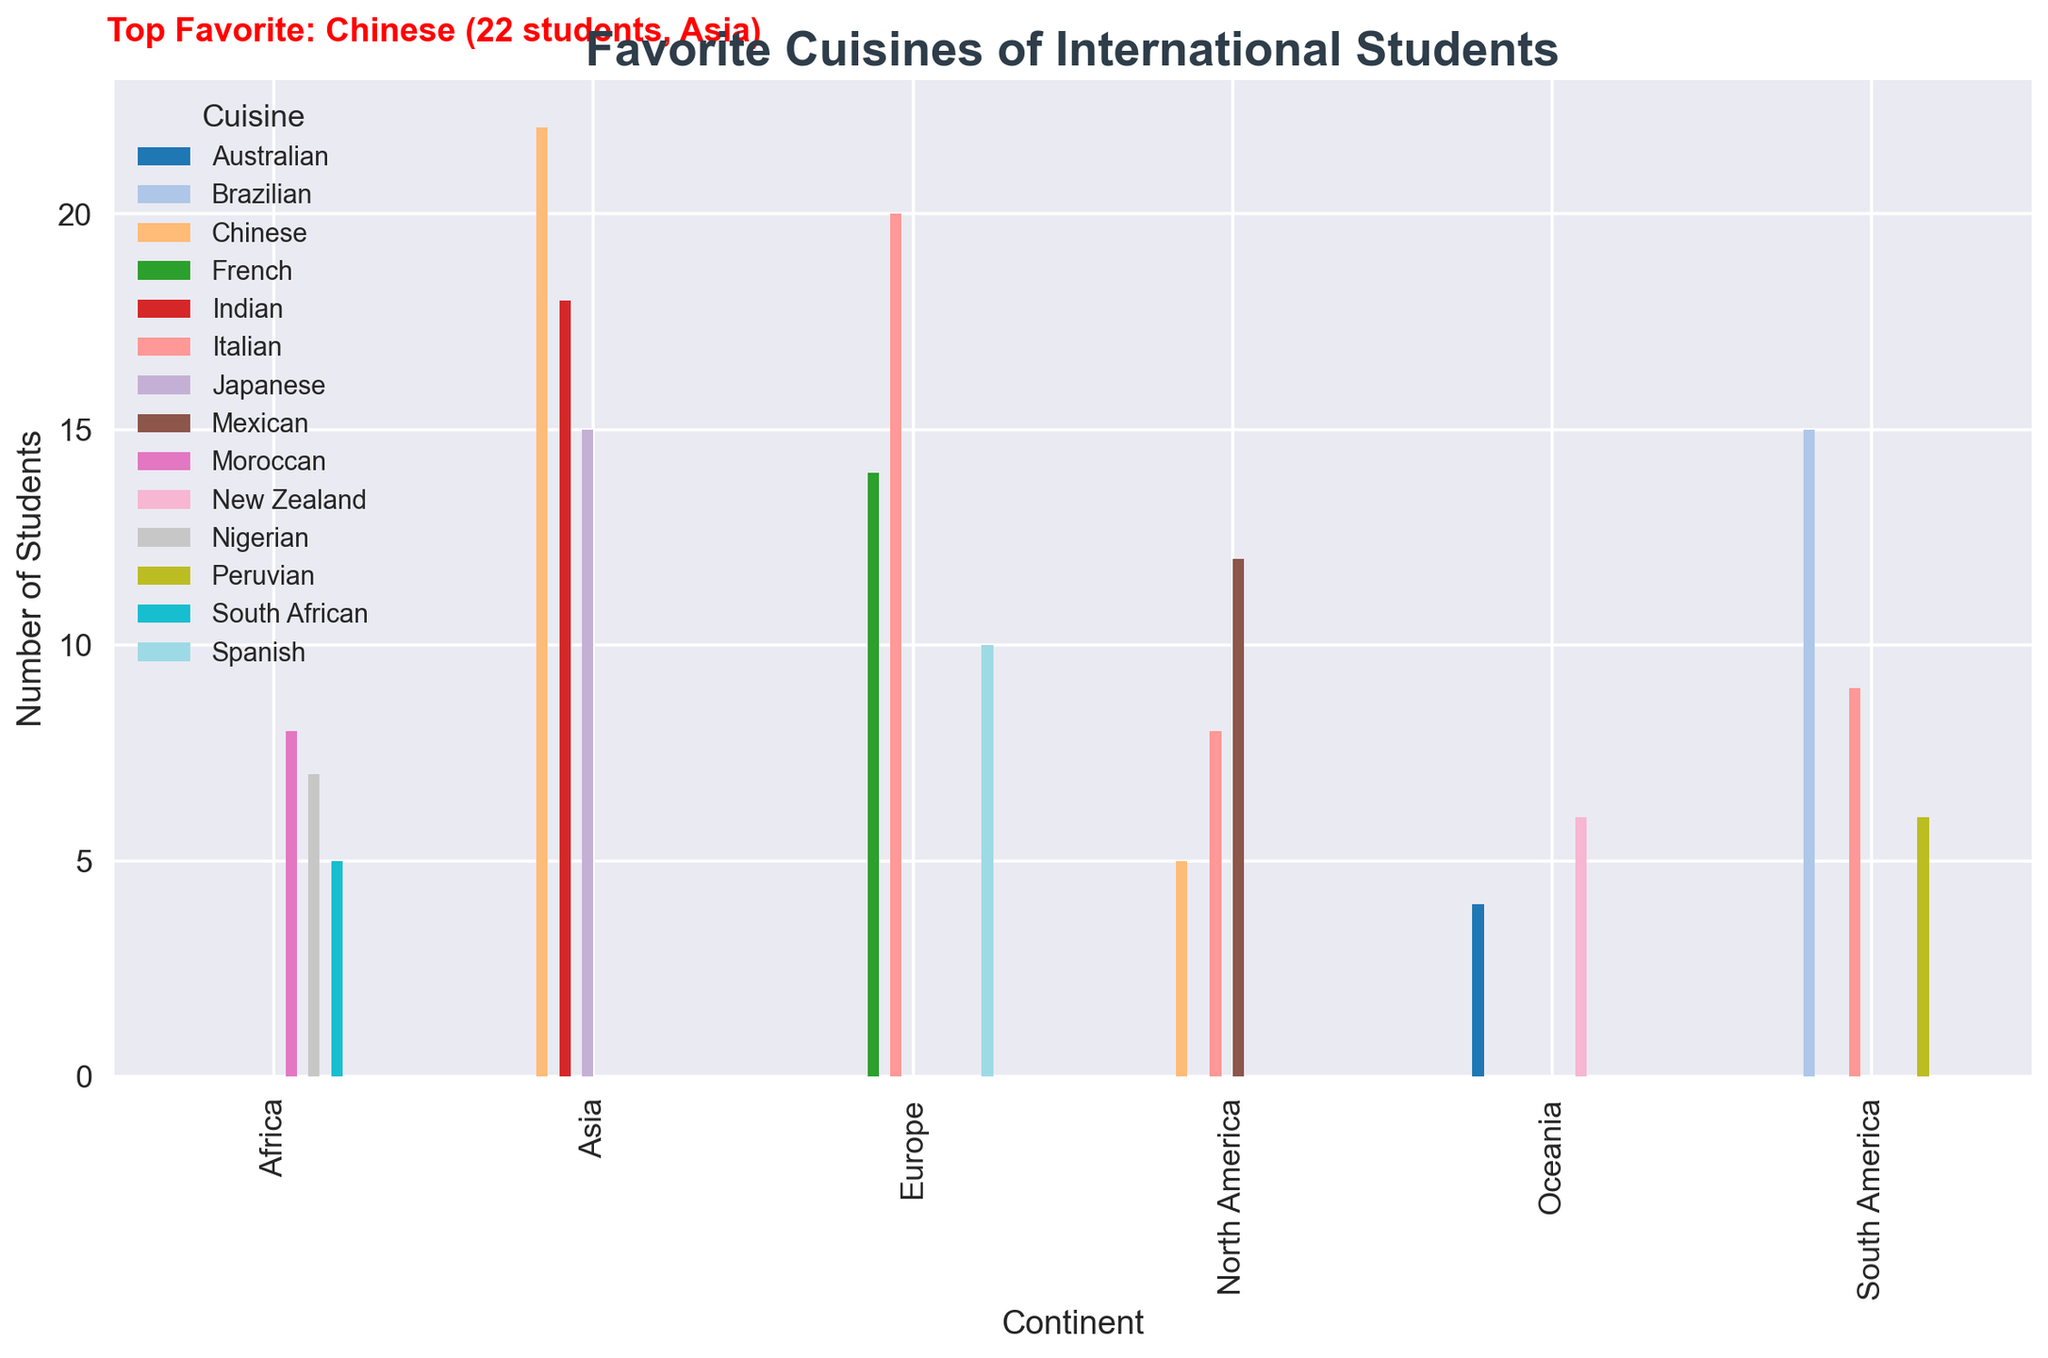What's the total number of students who prefer Italian cuisine across all continents? First, identify the number of students for Italian cuisine in each continent and then sum them up. North America has 8, South America has 9, and Europe has 20. Therefore, the total is 8 + 9 + 20 = 37.
Answer: 37 Which continent has the highest number of students preferring Chinese cuisine? Look at the bar heights for Chinese cuisine across continents. The values are North America (5), Asia (22). Among these, Asia has the highest with 22 students.
Answer: Asia How many more students prefer Mexican cuisine than Nigerian cuisine? Find the number of students who prefer Mexican (12) and Nigerian (7) cuisines, then subtract the latter from the former: 12 - 7 = 5.
Answer: 5 Which cuisine is most favored by students, and from which continent does this preference come? Look at the annotation which highlights the top favorite cuisine. It mentions Chinese cuisine with 22 students from Asia.
Answer: Chinese, Asia Compare the number of students preferring Peruvian and Indian cuisines. Which has more, and by how much? Find the bars for Peruvian (6) and Indian (18) cuisines and calculate the difference: 18 - 6 = 12. Indian has more than Peruvian by 12 students.
Answer: Indian, 12 Is there any continent where no students prefer Japanese cuisine? Look for bars representing Japanese cuisine in each continent. Only Asia has Japanese cuisine bars. Therefore, all other continents have no students preferring Japanese cuisine.
Answer: Yes Which continent has the least number of students for any single cuisine, and what is that cuisine? Identify the smallest bar height for any cuisine. Oceania has the smallest bar height for Australian cuisine with 4 students.
Answer: Oceania, Australian What is the total number of students surveyed in the apartment building? Sum up the "Number of Students" for all cuisines and continents. The total sum of all values in the dataset is 184.
Answer: 184 